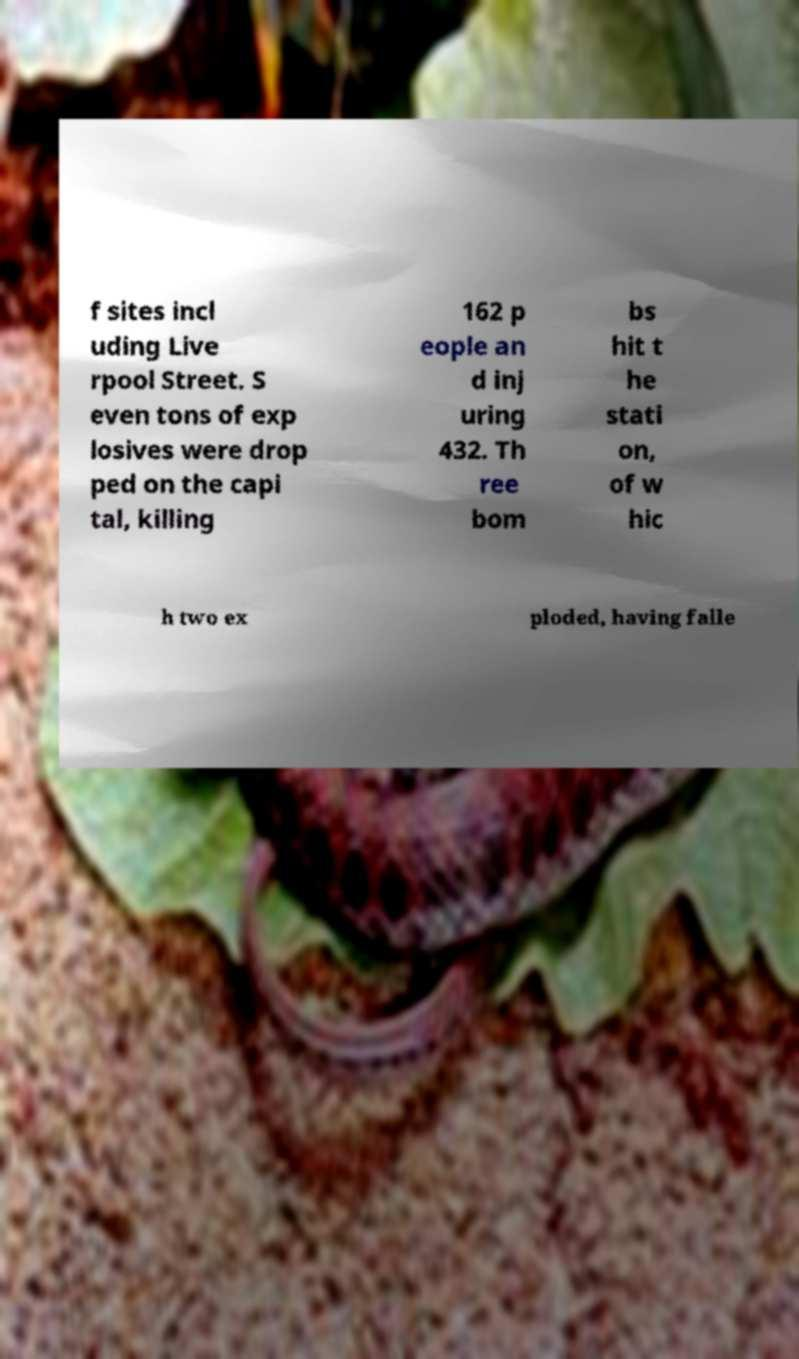Could you assist in decoding the text presented in this image and type it out clearly? f sites incl uding Live rpool Street. S even tons of exp losives were drop ped on the capi tal, killing 162 p eople an d inj uring 432. Th ree bom bs hit t he stati on, of w hic h two ex ploded, having falle 